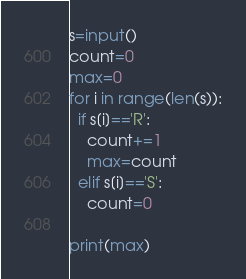<code> <loc_0><loc_0><loc_500><loc_500><_Python_>s=input()
count=0
max=0
for i in range(len(s)):
  if s[i]=='R':
    count+=1
    max=count
  elif s[i]=='S':
    count=0
      
print(max)</code> 